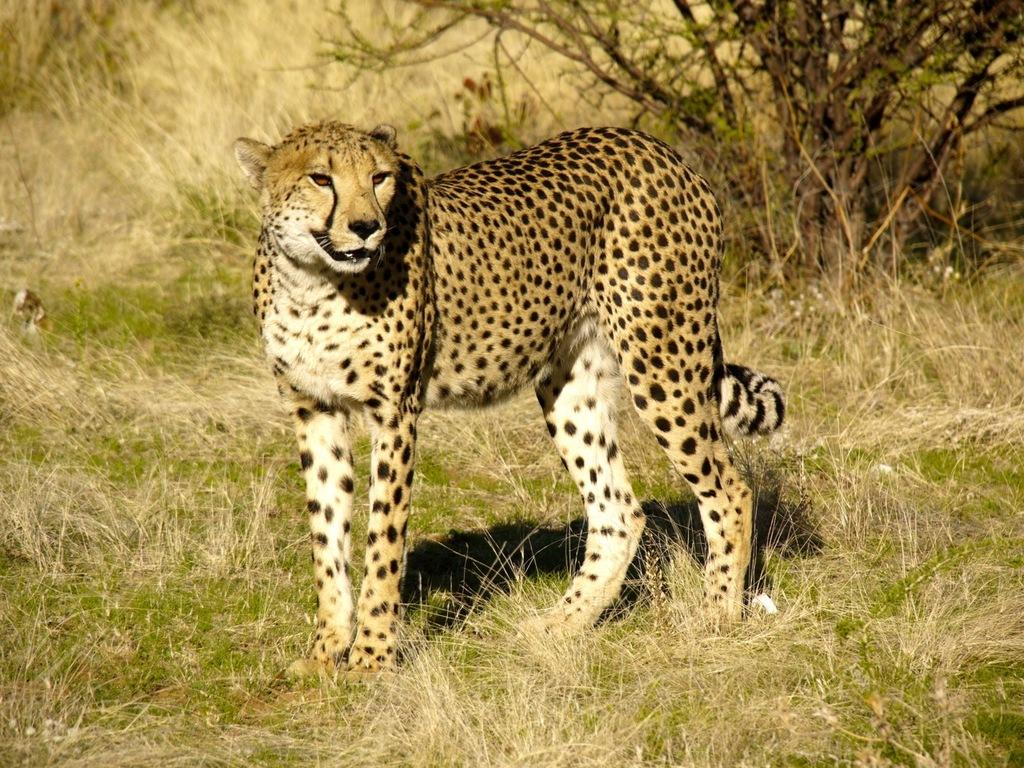What animal is the main subject of the picture? There is a cheetah in the picture. Where is the cheetah located in the image? The cheetah is on the ground. What can be seen in the background of the picture? There are plants visible in the background of the picture. What type of wristwatch is the cheetah wearing in the image? There is no wristwatch present in the image, as the cheetah is a wild animal and does not wear accessories. 